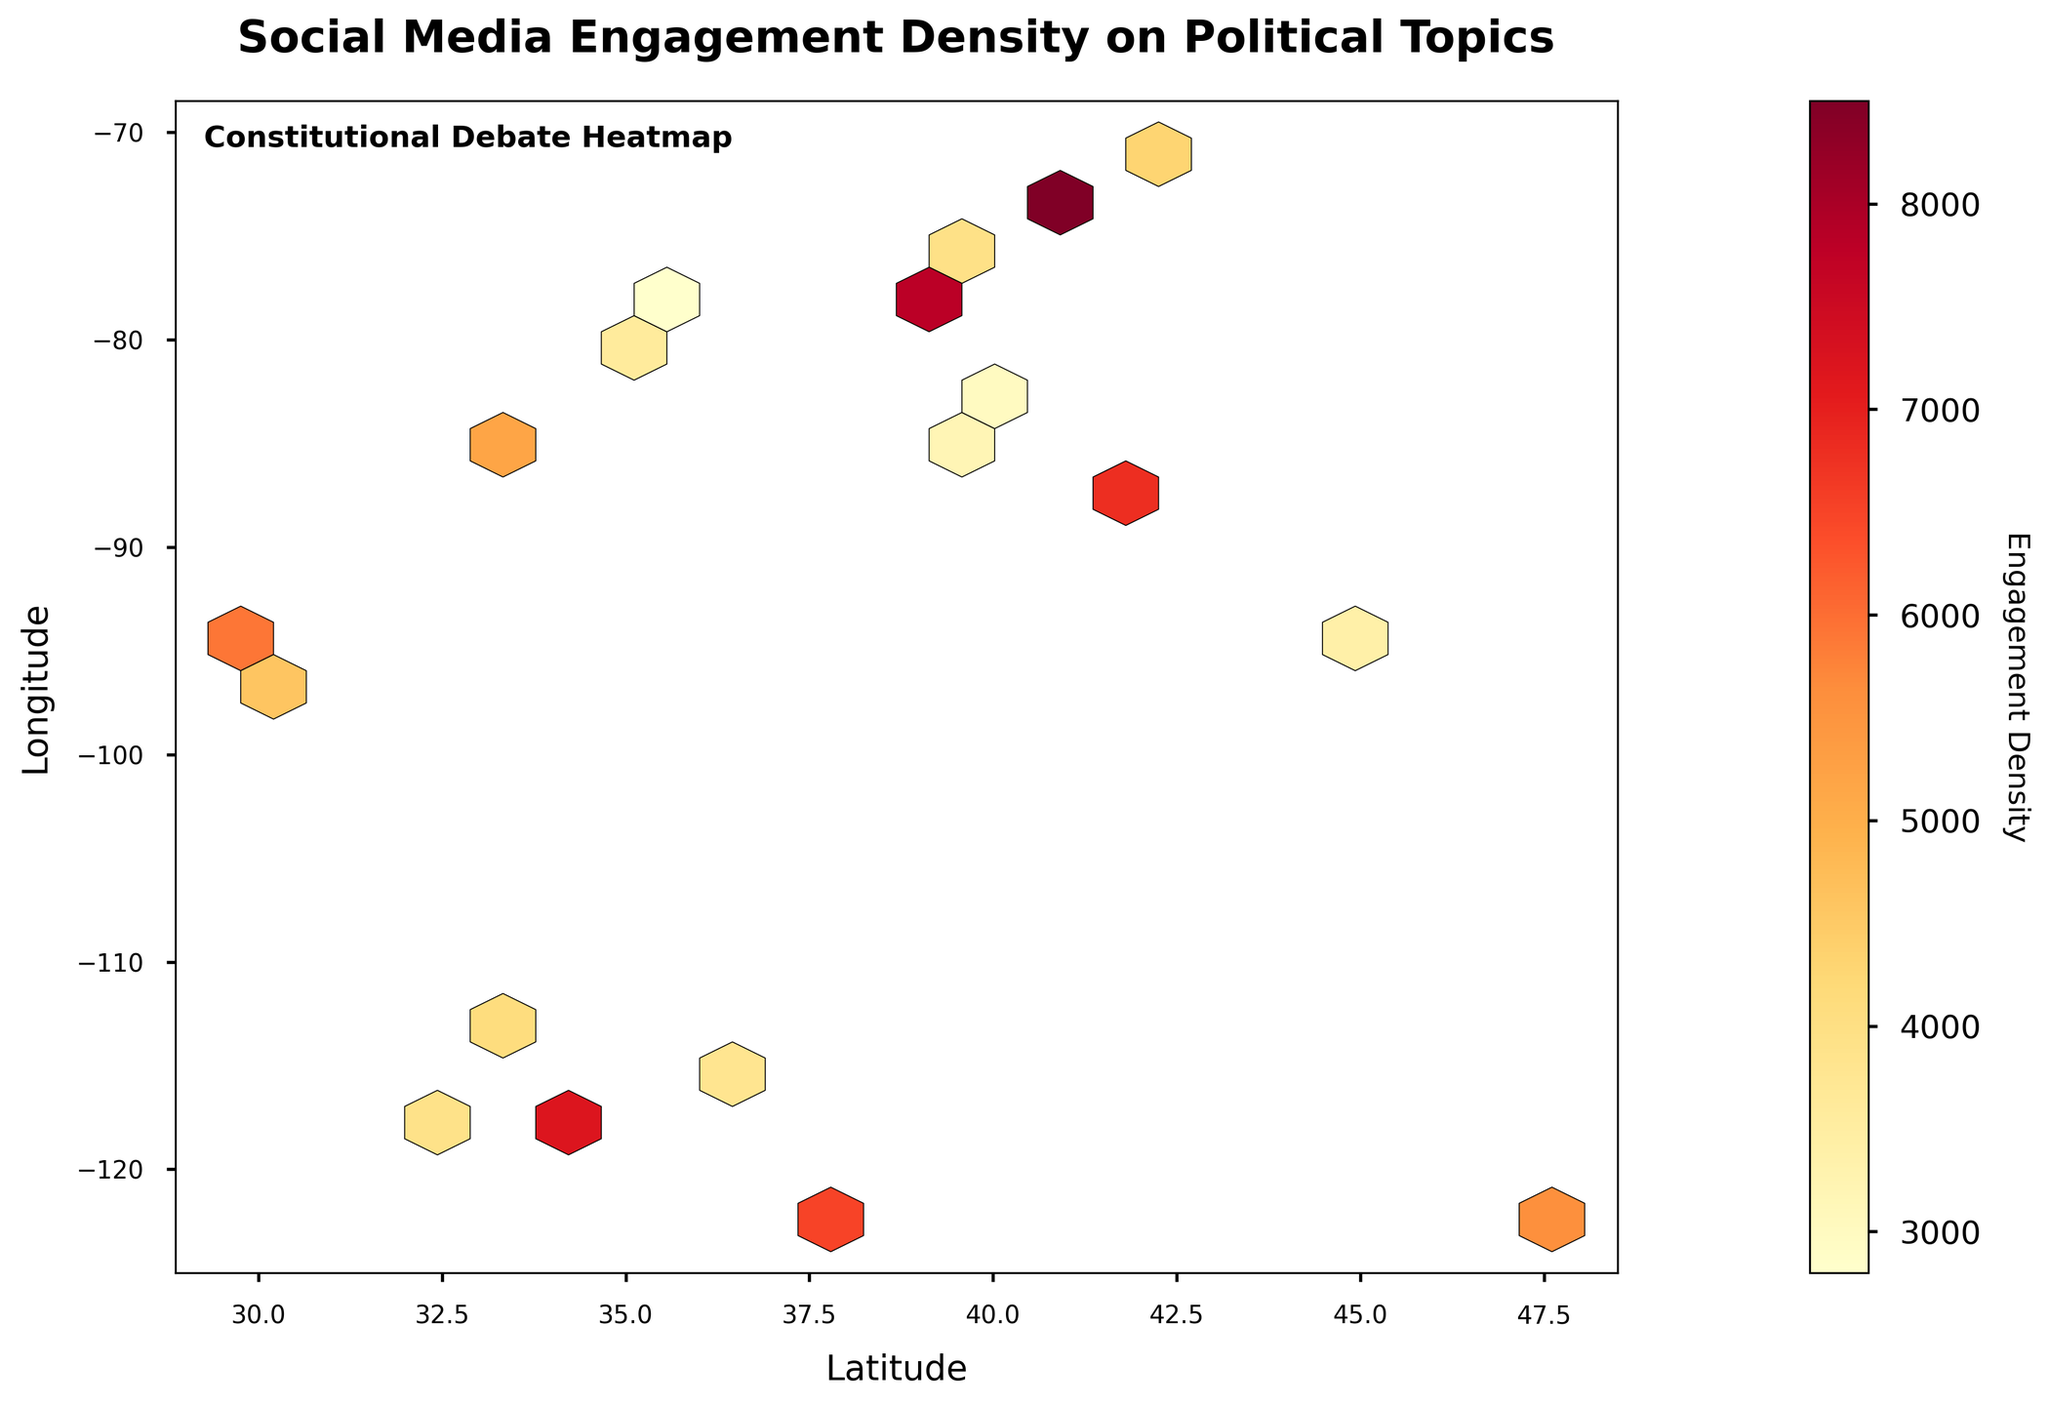What is the main title of the plot? The main title is typically found at the top of the plot. Reading it helps to understand the subject of the plot.
Answer: Social Media Engagement Density on Political Topics What does the color bar on the right side of the plot represent? The color bar indicates the engagement density levels, which helps to read the density of hexagons based on their colors.
Answer: Engagement Density Which city shows the highest density of social media engagement on political topics based on the plot? The hexagon with the darkest shade corresponds to the highest engagement density. New York City, as represented by coordinates (40.7128, -74.0060), has the highest density.
Answer: New York City How does the social media engagement density in Los Angeles compare to that in Chicago? Comparing hexagons near Los Angeles (34.0522, -118.2437) and Chicago (41.8781, -87.6298) by their color intensity helps to understand that Los Angeles has slightly higher density.
Answer: Los Angeles has slightly higher density What are the x and y axes labeled as on the plot? The labels of x and y axes, located alongside the axes, indicate what each axis represents. X axis represents latitude and Y axis represents longitude.
Answer: Latitude and Longitude Which regions in the plot show a medium level of engagement density based on the color gradient? Identifying regions with intermediate shades between the lightest and darkest colors, regions like Philadelphia (39.9526, -75.1652) and Houston (29.7604, -95.3698) show medium engagement density.
Answer: Philadelphia and Houston What trend can be observed about the social media engagement density range within these data points? Observing the color gradient from light to dark shows that engagement density varies significantly across different regions, with some regions having very high densities and others having low to medium densities.
Answer: Density varies significantly What does the hexagonal binning on this plot help achieve compared to a scatter plot? Hexagonal binning helps in visualizing the density of the data points more effectively than scatter plots by assigning color density to different regions.
Answer: Better density visualization Where is “Constitutional Debate Heatmap” located on the chart? The text "Constitutional Debate Heatmap" is located within the plot area, typically near one of the corners with a white box background for emphasis.
Answer: Near the top left corner What colors on the plot indicate the highest and lowest engagement densities? The color gradient indicates densities; the darkest shades indicate the highest engagement, and the lightest shades indicate the lowest. Dark red represents highest, and light yellow represents lowest.
Answer: Dark red for highest, light yellow for lowest 